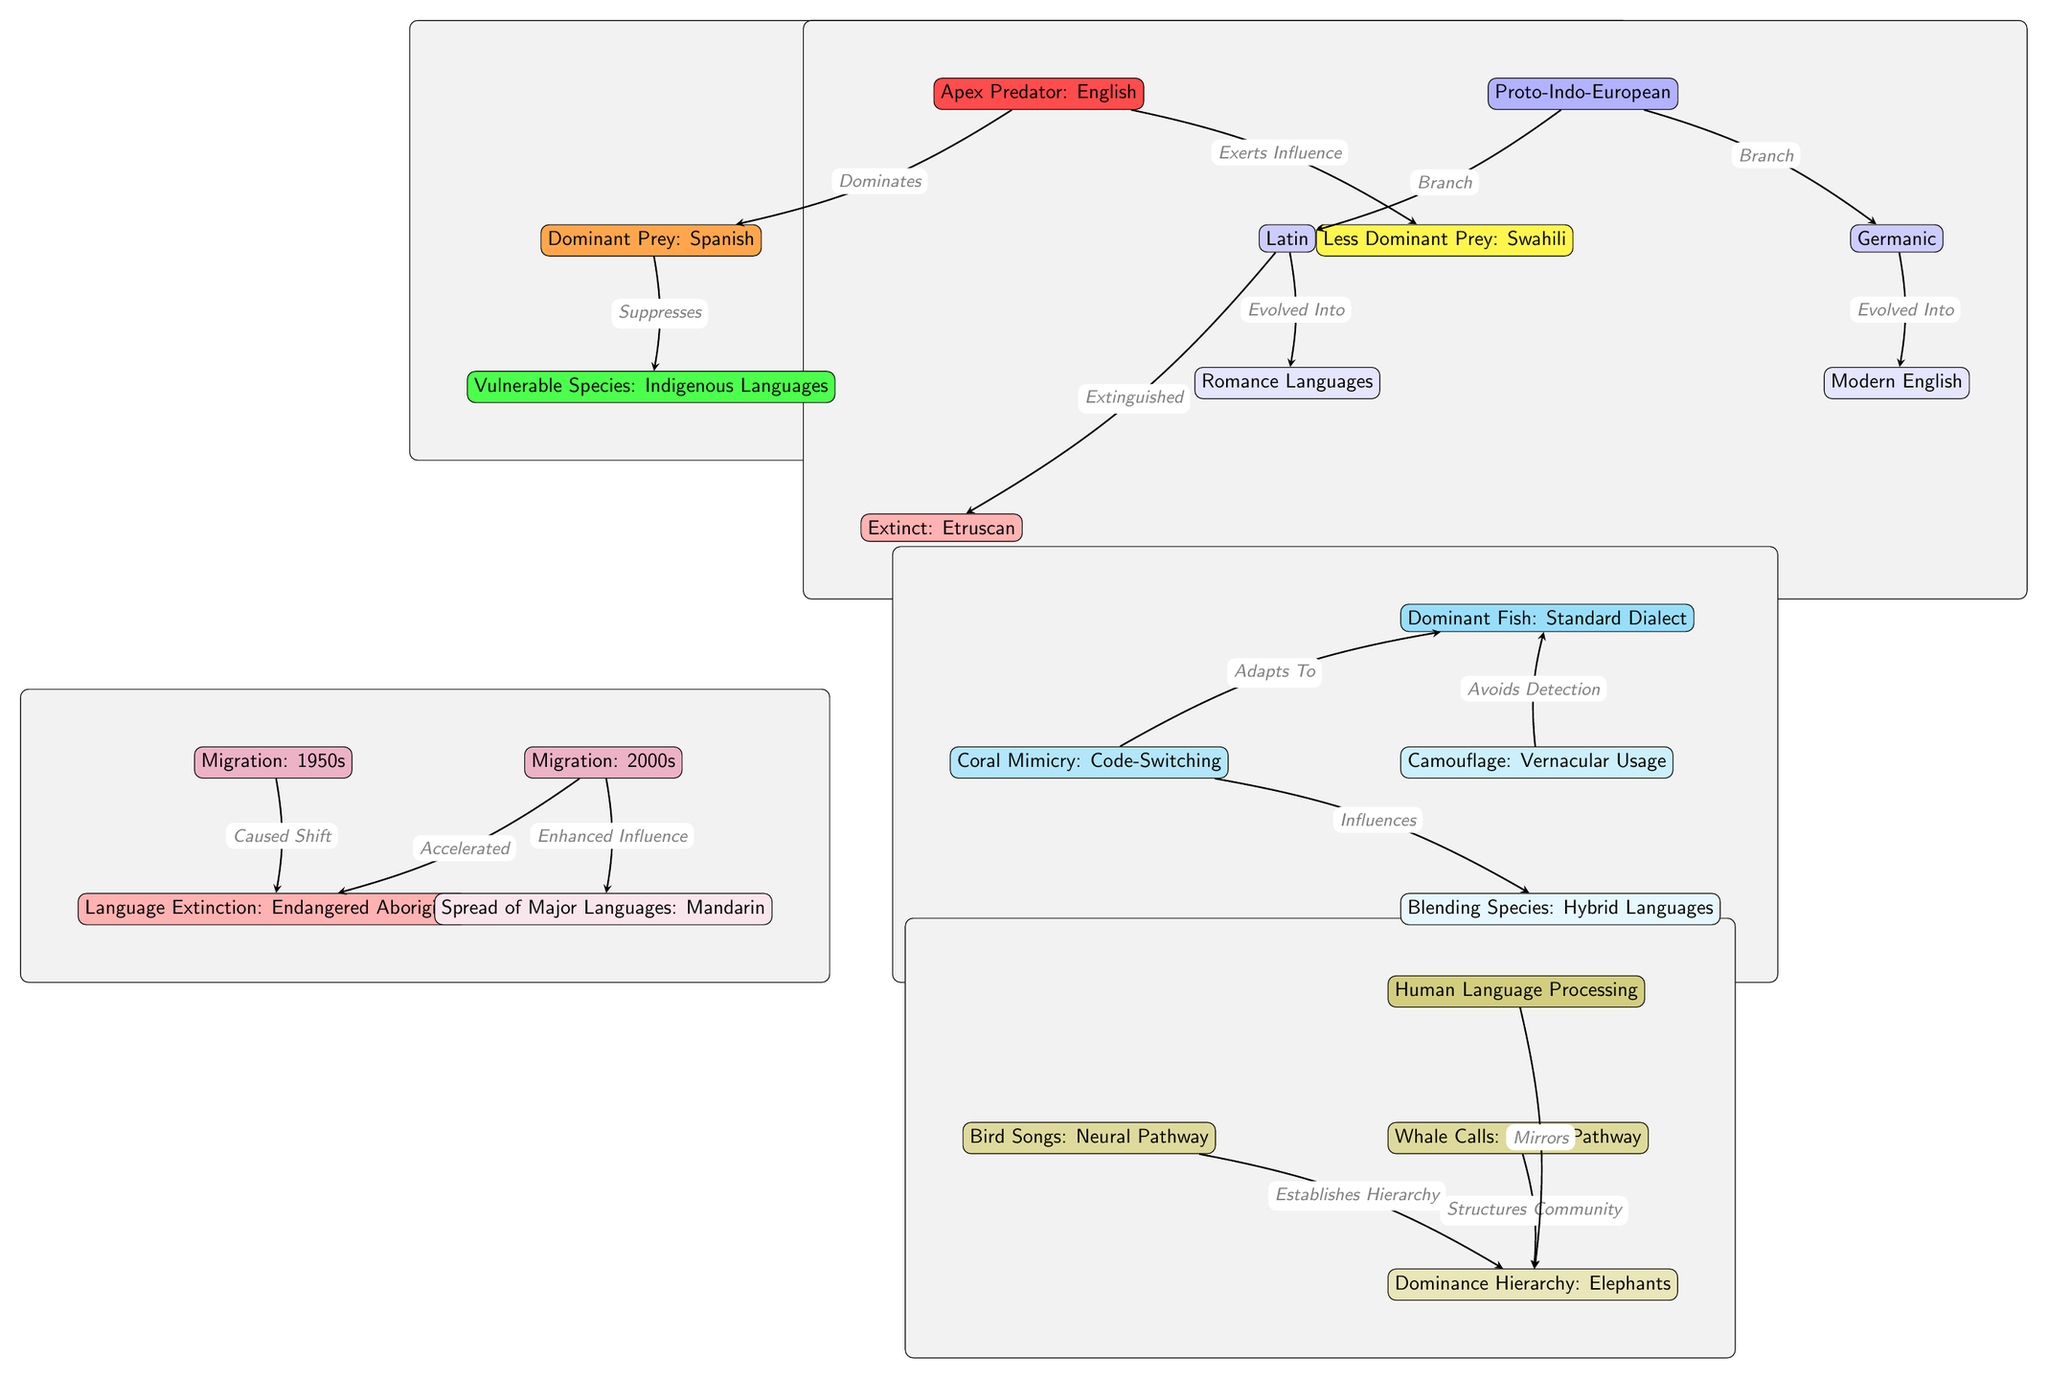What is the apex predator in this diagram? The diagram clearly labels the apex predator as "English." It is the topmost node in the ecosystem network, indicating its dominance.
Answer: English Which language is identified as the dominant prey? The diagram indicates "Spanish" as the dominant prey, which is positioned directly below and connects to the apex predator.
Answer: Spanish What do dominant species do to vulnerable species according to the diagram? The edge connecting the dominant species (Spanish) to the vulnerable species (Indigenous Languages) is labeled "Suppresses," indicating that the dominant species exerts control over the vulnerable ones.
Answer: Suppresses How many branches are formed from Proto-Indo-European? Moving from the Proto-Indo-European node, there are two branches shown in the diagram leading to Latin and Germanic. Therefore, there are two branches.
Answer: 2 What does the Coral Mimicry represent in the context of language? The Coral Mimicry is labeled as "Code-Switching" in the diagram, which suggests it illustrates the concept of languages adapting to different social contexts.
Answer: Code-Switching Which migration period is associated with language extinction in the diagram? The diagram indicates that the migration happening in the 1950s led to language extinction, specifically marked as "Language Extinction: Endangered Aboriginal."
Answer: 1950s What species establishes dominance hierarchy through communication, according to the diagram? The diagram shows that "Bird Songs" establish a dominance hierarchy, which indicates that communication through bird songs plays a role in social ranking within their species.
Answer: Bird Songs What is represented as being influenced by "Coral Mimicry"? According to the diagram, the edge from Coral Mimicry points to "Blending Species," labeled as "Hybrid Languages," suggesting influence in the context of adaptation.
Answer: Hybrid Languages What is the relationship between Major Languages spread and the Migration in the 2000s? The diagram shows an arrow from the 2000s migration to the spread of major languages, labeled "Enhanced Influence," indicating that migration has increased the spread and influence of major languages.
Answer: Enhanced Influence 